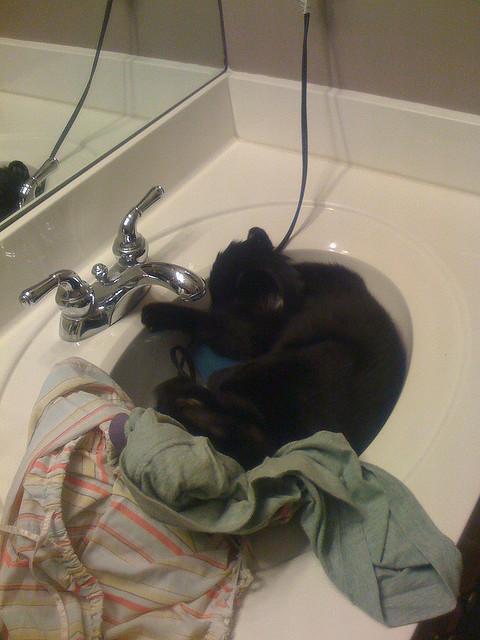How many sinks can you see?
Give a very brief answer. 1. 